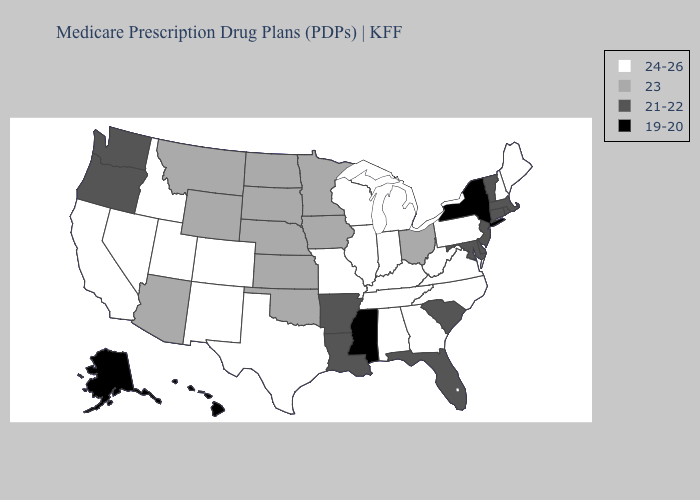Name the states that have a value in the range 23?
Write a very short answer. Arizona, Iowa, Kansas, Minnesota, Montana, North Dakota, Nebraska, Ohio, Oklahoma, South Dakota, Wyoming. What is the lowest value in the West?
Give a very brief answer. 19-20. Does Minnesota have a lower value than Iowa?
Concise answer only. No. Does Iowa have the lowest value in the MidWest?
Write a very short answer. Yes. Name the states that have a value in the range 23?
Concise answer only. Arizona, Iowa, Kansas, Minnesota, Montana, North Dakota, Nebraska, Ohio, Oklahoma, South Dakota, Wyoming. What is the value of New Hampshire?
Write a very short answer. 24-26. What is the lowest value in states that border Illinois?
Be succinct. 23. Name the states that have a value in the range 24-26?
Short answer required. Alabama, California, Colorado, Georgia, Idaho, Illinois, Indiana, Kentucky, Maine, Michigan, Missouri, North Carolina, New Hampshire, New Mexico, Nevada, Pennsylvania, Tennessee, Texas, Utah, Virginia, Wisconsin, West Virginia. What is the lowest value in the USA?
Answer briefly. 19-20. Name the states that have a value in the range 21-22?
Answer briefly. Arkansas, Connecticut, Delaware, Florida, Louisiana, Massachusetts, Maryland, New Jersey, Oregon, Rhode Island, South Carolina, Vermont, Washington. What is the value of South Carolina?
Short answer required. 21-22. What is the value of West Virginia?
Quick response, please. 24-26. How many symbols are there in the legend?
Concise answer only. 4. Among the states that border Virginia , does Kentucky have the highest value?
Concise answer only. Yes. Does Alaska have the lowest value in the USA?
Write a very short answer. Yes. 